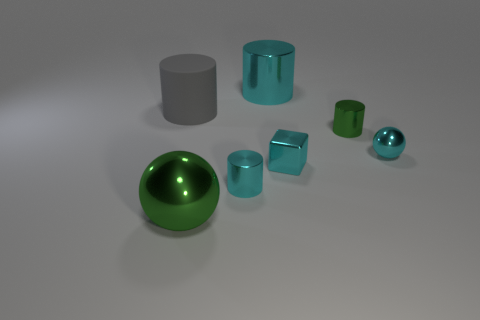Subtract all tiny green cylinders. How many cylinders are left? 3 Add 2 large gray things. How many objects exist? 9 Subtract all gray cylinders. How many cylinders are left? 3 Subtract all cylinders. How many objects are left? 3 Subtract 0 red cylinders. How many objects are left? 7 Subtract 2 spheres. How many spheres are left? 0 Subtract all yellow cubes. Subtract all green spheres. How many cubes are left? 1 Subtract all green balls. How many red cylinders are left? 0 Subtract all small rubber cylinders. Subtract all small metal spheres. How many objects are left? 6 Add 7 big green metallic balls. How many big green metallic balls are left? 8 